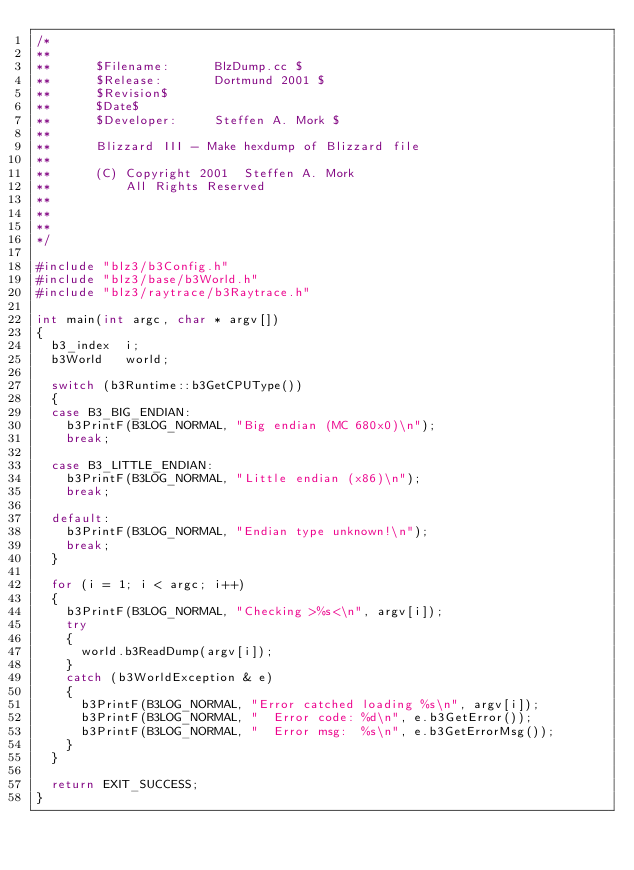<code> <loc_0><loc_0><loc_500><loc_500><_C++_>/*
**
**      $Filename:      BlzDump.cc $
**      $Release:       Dortmund 2001 $
**      $Revision$
**      $Date$
**      $Developer:     Steffen A. Mork $
**
**      Blizzard III - Make hexdump of Blizzard file
**
**      (C) Copyright 2001  Steffen A. Mork
**          All Rights Reserved
**
**
**
*/

#include "blz3/b3Config.h"
#include "blz3/base/b3World.h"
#include "blz3/raytrace/b3Raytrace.h"

int main(int argc, char * argv[])
{
	b3_index  i;
	b3World   world;

	switch (b3Runtime::b3GetCPUType())
	{
	case B3_BIG_ENDIAN:
		b3PrintF(B3LOG_NORMAL, "Big endian (MC 680x0)\n");
		break;

	case B3_LITTLE_ENDIAN:
		b3PrintF(B3LOG_NORMAL, "Little endian (x86)\n");
		break;

	default:
		b3PrintF(B3LOG_NORMAL, "Endian type unknown!\n");
		break;
	}

	for (i = 1; i < argc; i++)
	{
		b3PrintF(B3LOG_NORMAL, "Checking >%s<\n", argv[i]);
		try
		{
			world.b3ReadDump(argv[i]);
		}
		catch (b3WorldException & e)
		{
			b3PrintF(B3LOG_NORMAL, "Error catched loading %s\n", argv[i]);
			b3PrintF(B3LOG_NORMAL, "  Error code: %d\n", e.b3GetError());
			b3PrintF(B3LOG_NORMAL, "  Error msg:  %s\n", e.b3GetErrorMsg());
		}
	}

	return EXIT_SUCCESS;
}
</code> 